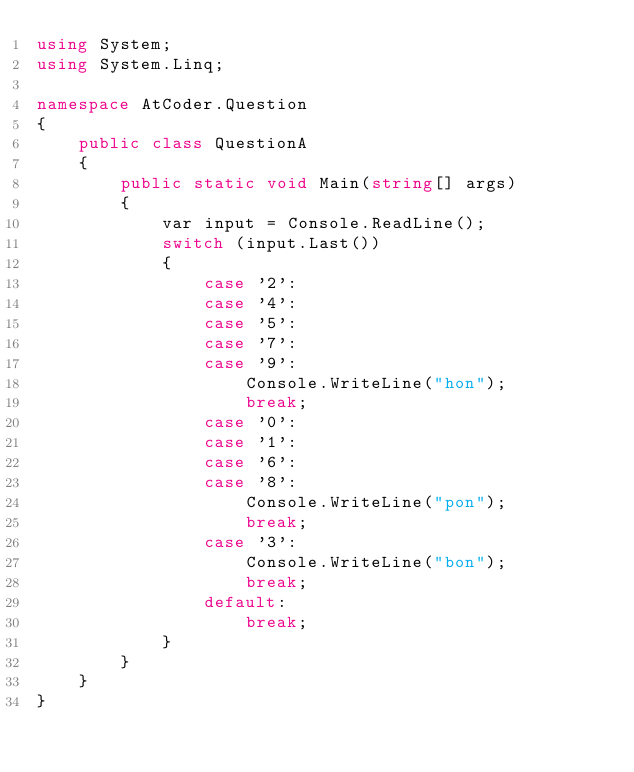Convert code to text. <code><loc_0><loc_0><loc_500><loc_500><_C#_>using System;
using System.Linq;

namespace AtCoder.Question
{
    public class QuestionA
    {
        public static void Main(string[] args)
        {
            var input = Console.ReadLine();
            switch (input.Last())
            {
                case '2':
                case '4':
                case '5':
                case '7':
                case '9':
                    Console.WriteLine("hon");
                    break;
                case '0':
                case '1':
                case '6':
                case '8':
                    Console.WriteLine("pon");
                    break;
                case '3':
                    Console.WriteLine("bon");
                    break;
                default:
                    break;
            }
        }
    }
}
</code> 